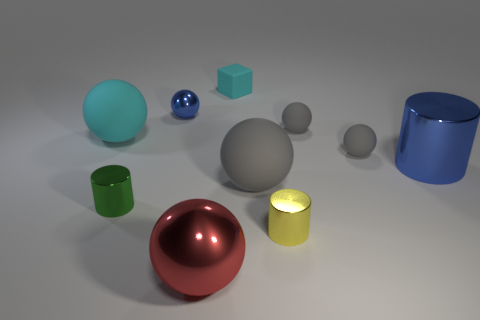Does the shiny thing that is right of the yellow thing have the same shape as the large red metal object?
Your answer should be very brief. No. Is the number of green metallic objects behind the large cyan ball greater than the number of tiny rubber objects?
Ensure brevity in your answer.  No. There is a tiny matte sphere behind the large rubber thing that is on the left side of the large gray object; what is its color?
Ensure brevity in your answer.  Gray. How many cyan objects are there?
Give a very brief answer. 2. What number of big things are behind the tiny green thing and in front of the blue cylinder?
Offer a very short reply. 1. Are there any other things that have the same shape as the small cyan thing?
Offer a very short reply. No. Is the color of the large metallic sphere the same as the metallic ball behind the large gray thing?
Your response must be concise. No. What shape is the large shiny object in front of the yellow shiny cylinder?
Your answer should be compact. Sphere. What number of other things are there of the same material as the large red thing
Ensure brevity in your answer.  4. What is the material of the large cyan sphere?
Give a very brief answer. Rubber. 